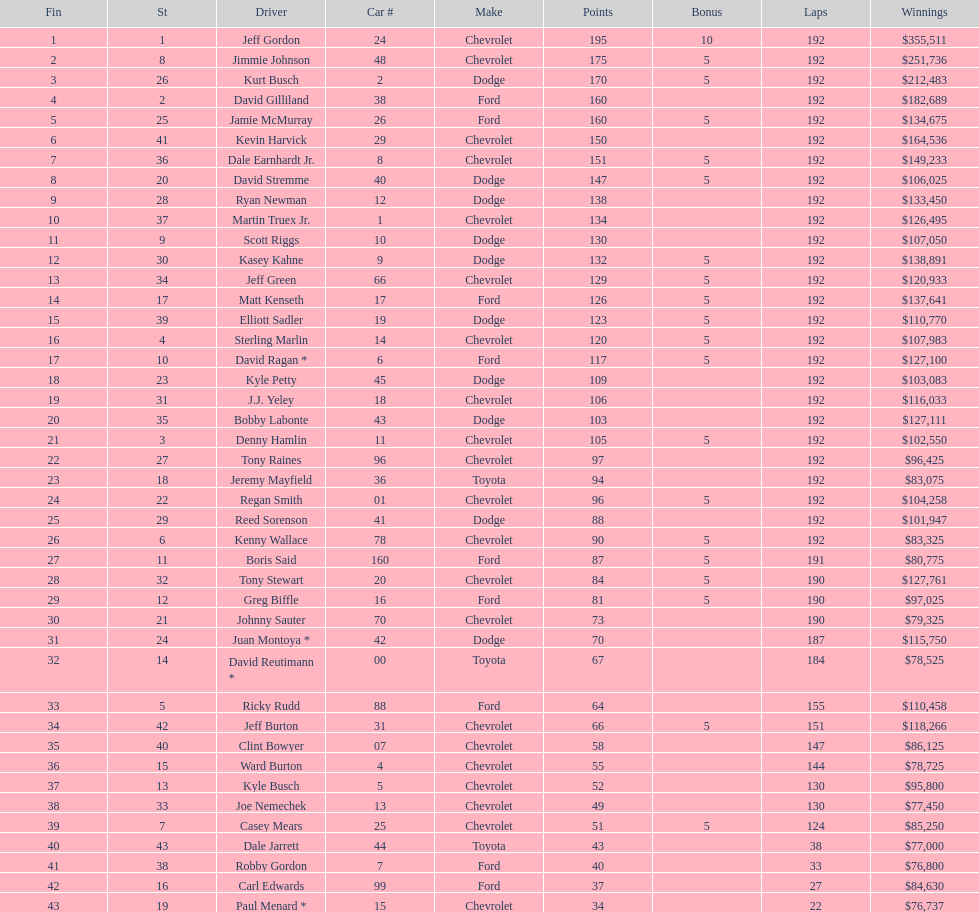Give me the full table as a dictionary. {'header': ['Fin', 'St', 'Driver', 'Car #', 'Make', 'Points', 'Bonus', 'Laps', 'Winnings'], 'rows': [['1', '1', 'Jeff Gordon', '24', 'Chevrolet', '195', '10', '192', '$355,511'], ['2', '8', 'Jimmie Johnson', '48', 'Chevrolet', '175', '5', '192', '$251,736'], ['3', '26', 'Kurt Busch', '2', 'Dodge', '170', '5', '192', '$212,483'], ['4', '2', 'David Gilliland', '38', 'Ford', '160', '', '192', '$182,689'], ['5', '25', 'Jamie McMurray', '26', 'Ford', '160', '5', '192', '$134,675'], ['6', '41', 'Kevin Harvick', '29', 'Chevrolet', '150', '', '192', '$164,536'], ['7', '36', 'Dale Earnhardt Jr.', '8', 'Chevrolet', '151', '5', '192', '$149,233'], ['8', '20', 'David Stremme', '40', 'Dodge', '147', '5', '192', '$106,025'], ['9', '28', 'Ryan Newman', '12', 'Dodge', '138', '', '192', '$133,450'], ['10', '37', 'Martin Truex Jr.', '1', 'Chevrolet', '134', '', '192', '$126,495'], ['11', '9', 'Scott Riggs', '10', 'Dodge', '130', '', '192', '$107,050'], ['12', '30', 'Kasey Kahne', '9', 'Dodge', '132', '5', '192', '$138,891'], ['13', '34', 'Jeff Green', '66', 'Chevrolet', '129', '5', '192', '$120,933'], ['14', '17', 'Matt Kenseth', '17', 'Ford', '126', '5', '192', '$137,641'], ['15', '39', 'Elliott Sadler', '19', 'Dodge', '123', '5', '192', '$110,770'], ['16', '4', 'Sterling Marlin', '14', 'Chevrolet', '120', '5', '192', '$107,983'], ['17', '10', 'David Ragan *', '6', 'Ford', '117', '5', '192', '$127,100'], ['18', '23', 'Kyle Petty', '45', 'Dodge', '109', '', '192', '$103,083'], ['19', '31', 'J.J. Yeley', '18', 'Chevrolet', '106', '', '192', '$116,033'], ['20', '35', 'Bobby Labonte', '43', 'Dodge', '103', '', '192', '$127,111'], ['21', '3', 'Denny Hamlin', '11', 'Chevrolet', '105', '5', '192', '$102,550'], ['22', '27', 'Tony Raines', '96', 'Chevrolet', '97', '', '192', '$96,425'], ['23', '18', 'Jeremy Mayfield', '36', 'Toyota', '94', '', '192', '$83,075'], ['24', '22', 'Regan Smith', '01', 'Chevrolet', '96', '5', '192', '$104,258'], ['25', '29', 'Reed Sorenson', '41', 'Dodge', '88', '', '192', '$101,947'], ['26', '6', 'Kenny Wallace', '78', 'Chevrolet', '90', '5', '192', '$83,325'], ['27', '11', 'Boris Said', '160', 'Ford', '87', '5', '191', '$80,775'], ['28', '32', 'Tony Stewart', '20', 'Chevrolet', '84', '5', '190', '$127,761'], ['29', '12', 'Greg Biffle', '16', 'Ford', '81', '5', '190', '$97,025'], ['30', '21', 'Johnny Sauter', '70', 'Chevrolet', '73', '', '190', '$79,325'], ['31', '24', 'Juan Montoya *', '42', 'Dodge', '70', '', '187', '$115,750'], ['32', '14', 'David Reutimann *', '00', 'Toyota', '67', '', '184', '$78,525'], ['33', '5', 'Ricky Rudd', '88', 'Ford', '64', '', '155', '$110,458'], ['34', '42', 'Jeff Burton', '31', 'Chevrolet', '66', '5', '151', '$118,266'], ['35', '40', 'Clint Bowyer', '07', 'Chevrolet', '58', '', '147', '$86,125'], ['36', '15', 'Ward Burton', '4', 'Chevrolet', '55', '', '144', '$78,725'], ['37', '13', 'Kyle Busch', '5', 'Chevrolet', '52', '', '130', '$95,800'], ['38', '33', 'Joe Nemechek', '13', 'Chevrolet', '49', '', '130', '$77,450'], ['39', '7', 'Casey Mears', '25', 'Chevrolet', '51', '5', '124', '$85,250'], ['40', '43', 'Dale Jarrett', '44', 'Toyota', '43', '', '38', '$77,000'], ['41', '38', 'Robby Gordon', '7', 'Ford', '40', '', '33', '$76,800'], ['42', '16', 'Carl Edwards', '99', 'Ford', '37', '', '27', '$84,630'], ['43', '19', 'Paul Menard *', '15', 'Chevrolet', '34', '', '22', '$76,737']]} Which make had the most consecutive finishes at the aarons 499? Chevrolet. 